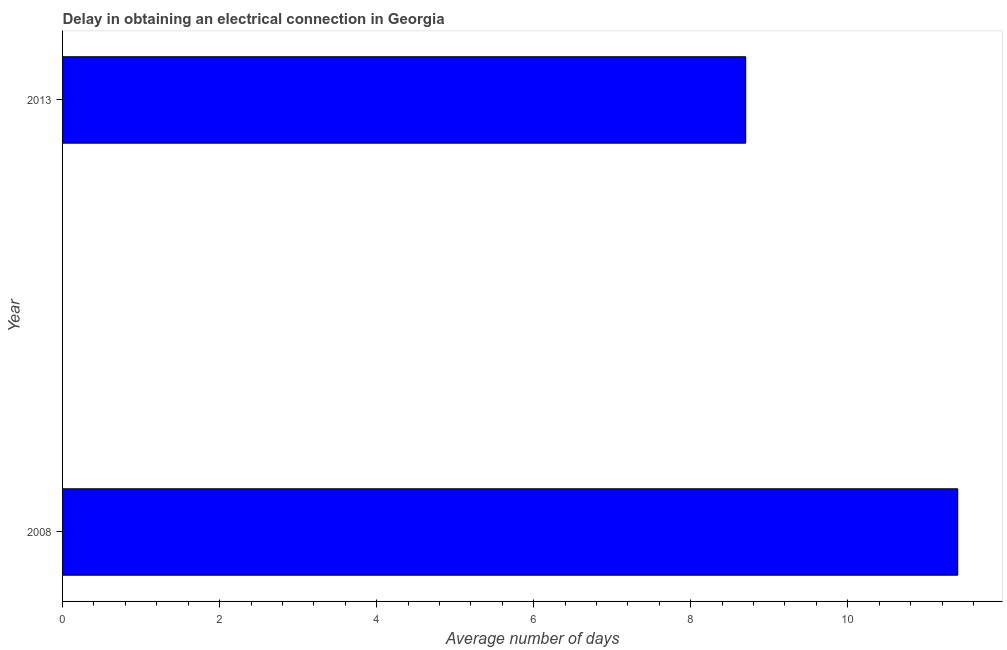Does the graph contain any zero values?
Offer a terse response. No. What is the title of the graph?
Give a very brief answer. Delay in obtaining an electrical connection in Georgia. What is the label or title of the X-axis?
Provide a short and direct response. Average number of days. What is the label or title of the Y-axis?
Provide a succinct answer. Year. Across all years, what is the minimum dalay in electrical connection?
Give a very brief answer. 8.7. In which year was the dalay in electrical connection maximum?
Make the answer very short. 2008. In which year was the dalay in electrical connection minimum?
Provide a short and direct response. 2013. What is the sum of the dalay in electrical connection?
Provide a short and direct response. 20.1. What is the difference between the dalay in electrical connection in 2008 and 2013?
Your response must be concise. 2.7. What is the average dalay in electrical connection per year?
Offer a very short reply. 10.05. What is the median dalay in electrical connection?
Offer a very short reply. 10.05. In how many years, is the dalay in electrical connection greater than 9.2 days?
Provide a short and direct response. 1. Do a majority of the years between 2008 and 2013 (inclusive) have dalay in electrical connection greater than 5.6 days?
Your response must be concise. Yes. What is the ratio of the dalay in electrical connection in 2008 to that in 2013?
Your response must be concise. 1.31. In how many years, is the dalay in electrical connection greater than the average dalay in electrical connection taken over all years?
Offer a terse response. 1. How many years are there in the graph?
Your answer should be very brief. 2. What is the difference between two consecutive major ticks on the X-axis?
Provide a short and direct response. 2. What is the Average number of days of 2008?
Offer a terse response. 11.4. What is the Average number of days of 2013?
Provide a short and direct response. 8.7. What is the difference between the Average number of days in 2008 and 2013?
Provide a short and direct response. 2.7. What is the ratio of the Average number of days in 2008 to that in 2013?
Your answer should be very brief. 1.31. 